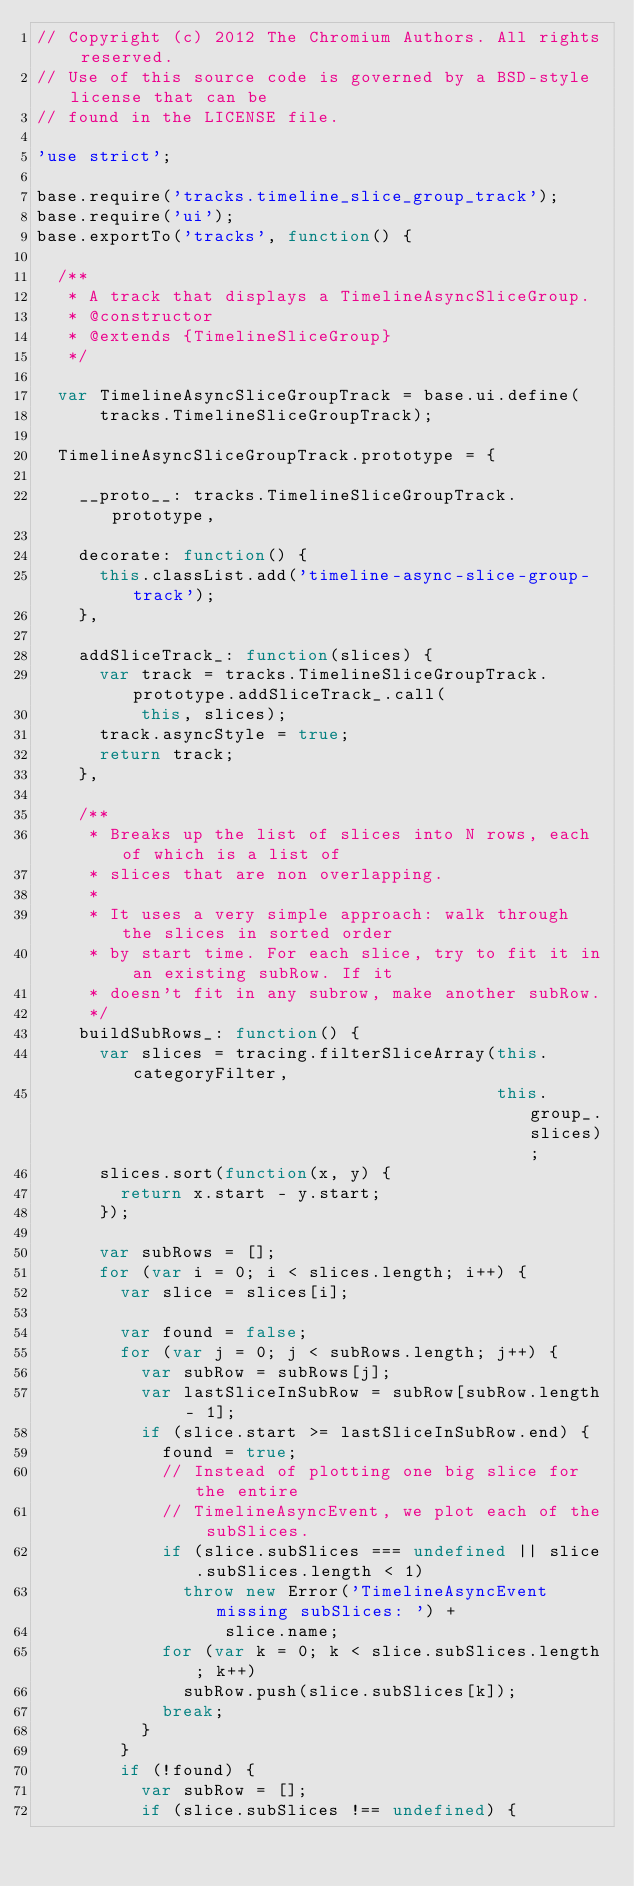Convert code to text. <code><loc_0><loc_0><loc_500><loc_500><_JavaScript_>// Copyright (c) 2012 The Chromium Authors. All rights reserved.
// Use of this source code is governed by a BSD-style license that can be
// found in the LICENSE file.

'use strict';

base.require('tracks.timeline_slice_group_track');
base.require('ui');
base.exportTo('tracks', function() {

  /**
   * A track that displays a TimelineAsyncSliceGroup.
   * @constructor
   * @extends {TimelineSliceGroup}
   */

  var TimelineAsyncSliceGroupTrack = base.ui.define(
      tracks.TimelineSliceGroupTrack);

  TimelineAsyncSliceGroupTrack.prototype = {

    __proto__: tracks.TimelineSliceGroupTrack.prototype,

    decorate: function() {
      this.classList.add('timeline-async-slice-group-track');
    },

    addSliceTrack_: function(slices) {
      var track = tracks.TimelineSliceGroupTrack.prototype.addSliceTrack_.call(
          this, slices);
      track.asyncStyle = true;
      return track;
    },

    /**
     * Breaks up the list of slices into N rows, each of which is a list of
     * slices that are non overlapping.
     *
     * It uses a very simple approach: walk through the slices in sorted order
     * by start time. For each slice, try to fit it in an existing subRow. If it
     * doesn't fit in any subrow, make another subRow.
     */
    buildSubRows_: function() {
      var slices = tracing.filterSliceArray(this.categoryFilter,
                                            this.group_.slices);
      slices.sort(function(x, y) {
        return x.start - y.start;
      });

      var subRows = [];
      for (var i = 0; i < slices.length; i++) {
        var slice = slices[i];

        var found = false;
        for (var j = 0; j < subRows.length; j++) {
          var subRow = subRows[j];
          var lastSliceInSubRow = subRow[subRow.length - 1];
          if (slice.start >= lastSliceInSubRow.end) {
            found = true;
            // Instead of plotting one big slice for the entire
            // TimelineAsyncEvent, we plot each of the subSlices.
            if (slice.subSlices === undefined || slice.subSlices.length < 1)
              throw new Error('TimelineAsyncEvent missing subSlices: ') +
                  slice.name;
            for (var k = 0; k < slice.subSlices.length; k++)
              subRow.push(slice.subSlices[k]);
            break;
          }
        }
        if (!found) {
          var subRow = [];
          if (slice.subSlices !== undefined) {</code> 